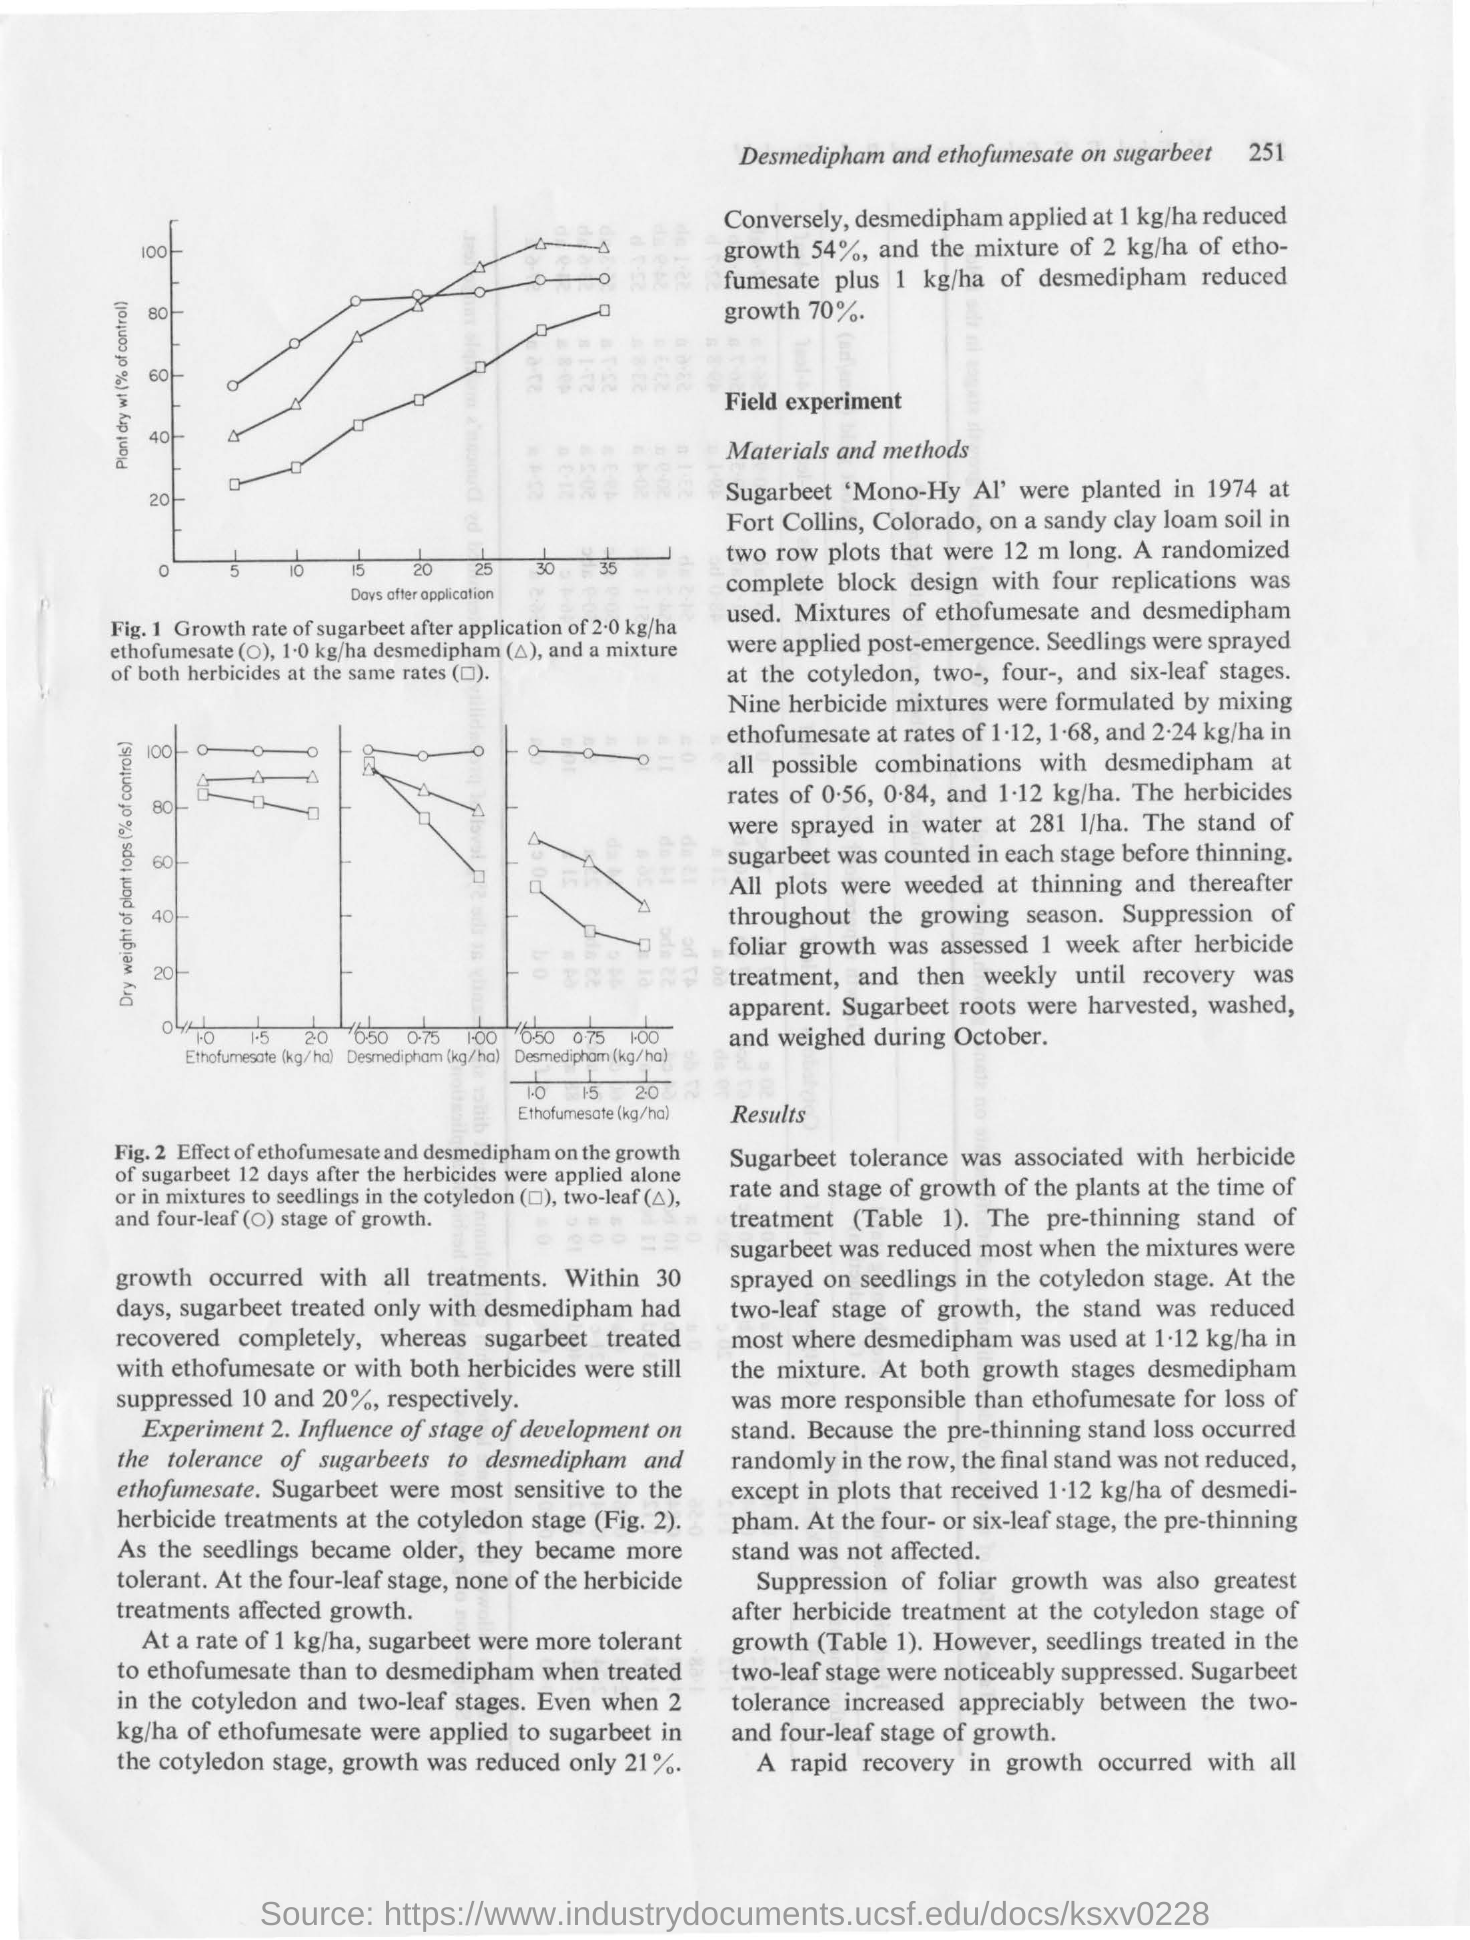List a handful of essential elements in this visual. The title on the y-axis of Figure 2 is "Dry weight of plant tops (% of controls)". The title on the y-axis of Figure 1 is "Plant Dry Weight (% of Control)". The title on the x-axis of Figure 1 is 'days after application'. 